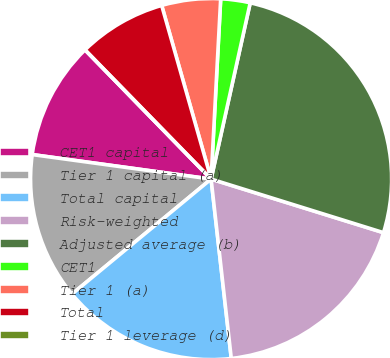<chart> <loc_0><loc_0><loc_500><loc_500><pie_chart><fcel>CET1 capital<fcel>Tier 1 capital (a)<fcel>Total capital<fcel>Risk-weighted<fcel>Adjusted average (b)<fcel>CET1<fcel>Tier 1 (a)<fcel>Total<fcel>Tier 1 leverage (d)<nl><fcel>10.53%<fcel>13.16%<fcel>15.79%<fcel>18.42%<fcel>26.32%<fcel>2.63%<fcel>5.26%<fcel>7.89%<fcel>0.0%<nl></chart> 